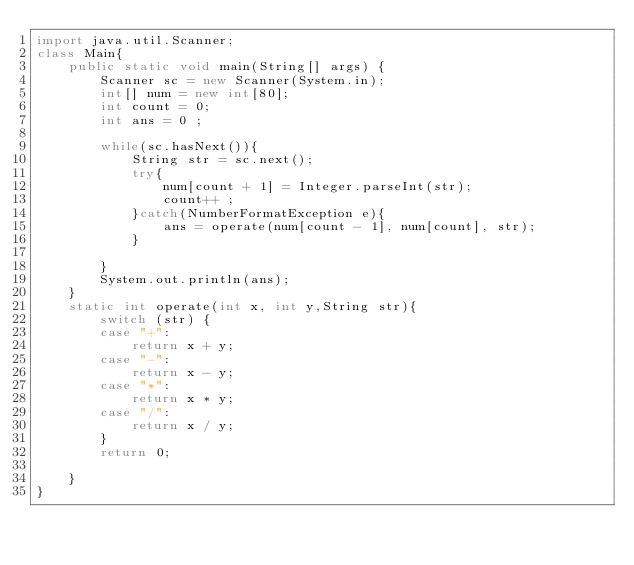<code> <loc_0><loc_0><loc_500><loc_500><_Java_>import java.util.Scanner;
class Main{
	public static void main(String[] args) {
		Scanner sc = new Scanner(System.in);
		int[] num = new int[80];
		int count = 0;
		int ans = 0 ;
				
		while(sc.hasNext()){
			String str = sc.next();
			try{
				num[count + 1] = Integer.parseInt(str);
				count++ ;
			}catch(NumberFormatException e){
				ans = operate(num[count - 1], num[count], str);
			}
			
		}
		System.out.println(ans);
	}
	static int operate(int x, int y,String str){
		switch (str) {
		case "+":
			return x + y;
		case "-":
			return x - y;
		case "*":
			return x * y;
		case "/":
			return x / y;
		}
		return 0;
		
	}
}</code> 